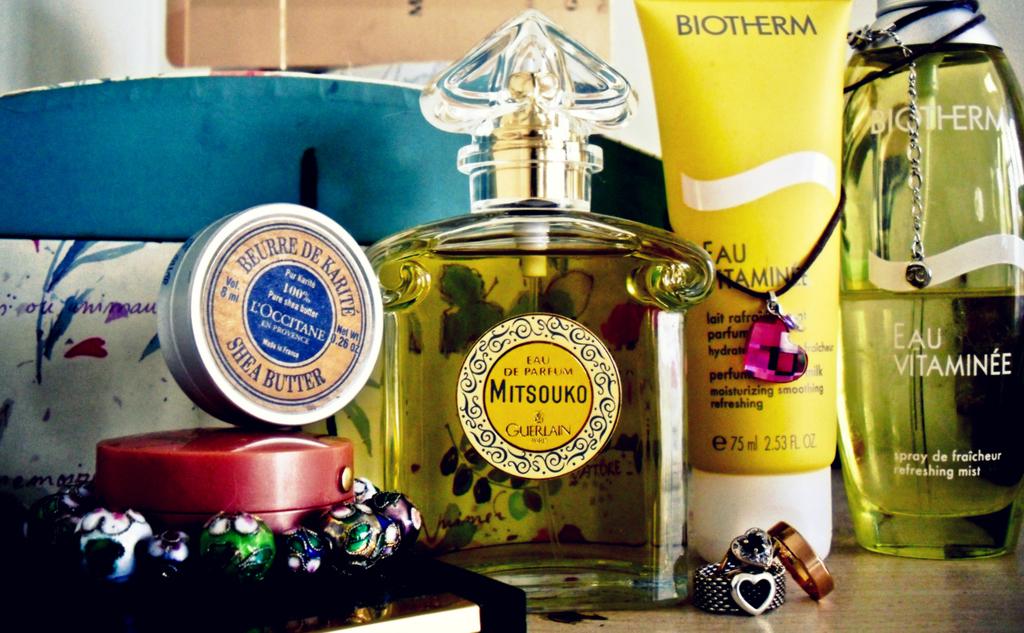What are the brands of these skin care products?
Offer a very short reply. Biotherm. What brand is that perfume in the big bottle?
Keep it short and to the point. Mitsouko. 